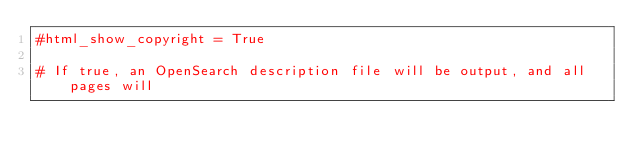Convert code to text. <code><loc_0><loc_0><loc_500><loc_500><_Python_>#html_show_copyright = True

# If true, an OpenSearch description file will be output, and all pages will</code> 